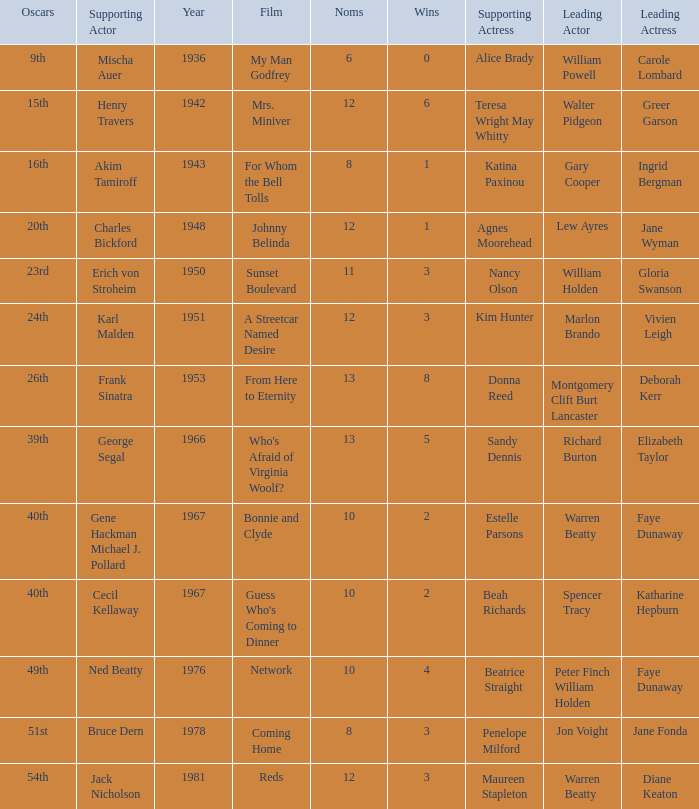Who was the supporting actress in 1943? Katina Paxinou. 